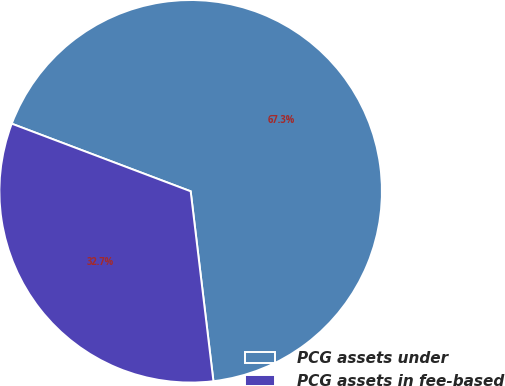Convert chart. <chart><loc_0><loc_0><loc_500><loc_500><pie_chart><fcel>PCG assets under<fcel>PCG assets in fee-based<nl><fcel>67.35%<fcel>32.65%<nl></chart> 